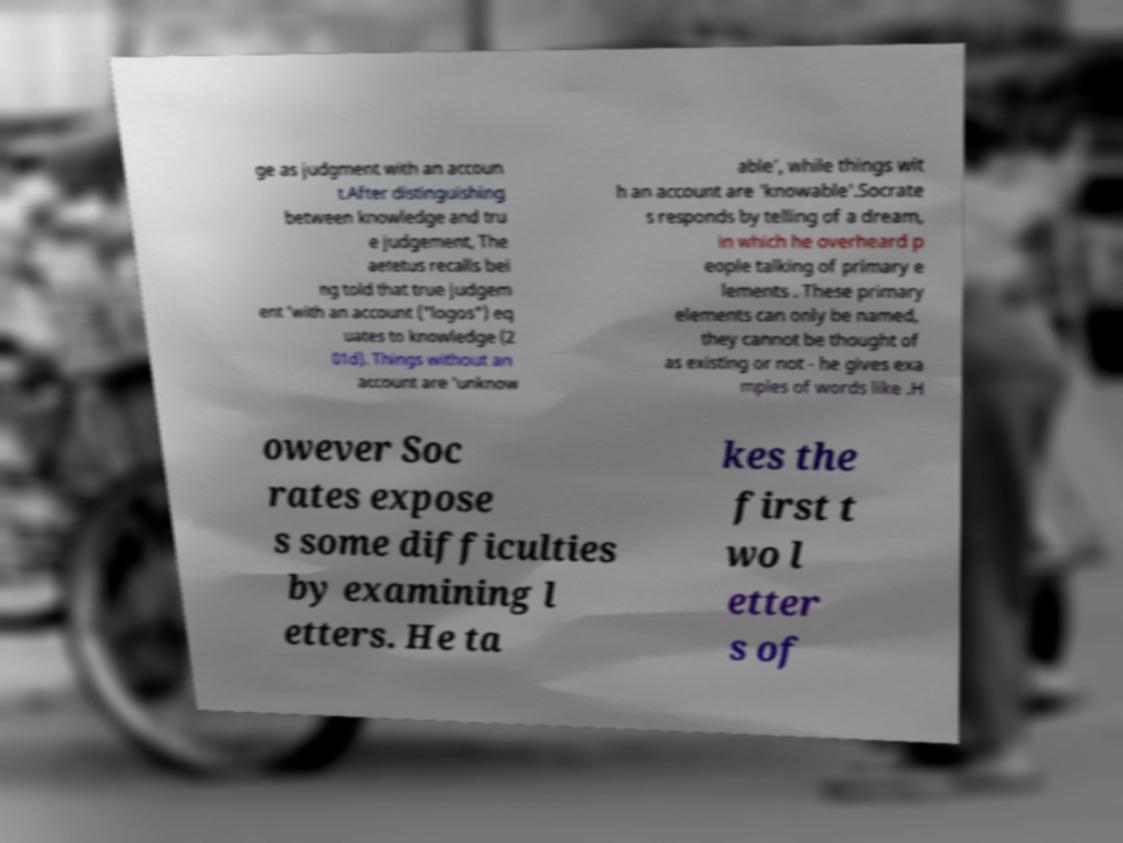What messages or text are displayed in this image? I need them in a readable, typed format. ge as judgment with an accoun t.After distinguishing between knowledge and tru e judgement, The aetetus recalls bei ng told that true judgem ent 'with an account ("logos") eq uates to knowledge (2 01d). Things without an account are 'unknow able', while things wit h an account are 'knowable'.Socrate s responds by telling of a dream, in which he overheard p eople talking of primary e lements . These primary elements can only be named, they cannot be thought of as existing or not - he gives exa mples of words like .H owever Soc rates expose s some difficulties by examining l etters. He ta kes the first t wo l etter s of 